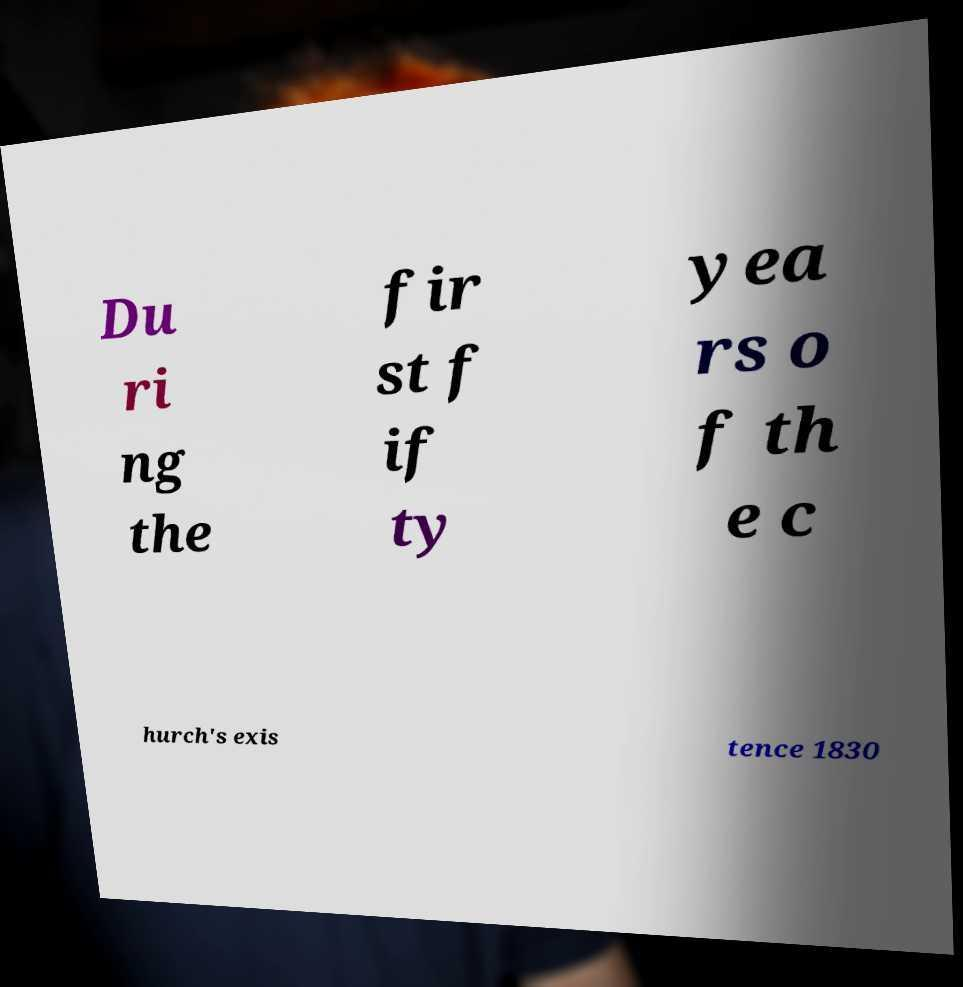Could you extract and type out the text from this image? Du ri ng the fir st f if ty yea rs o f th e c hurch's exis tence 1830 